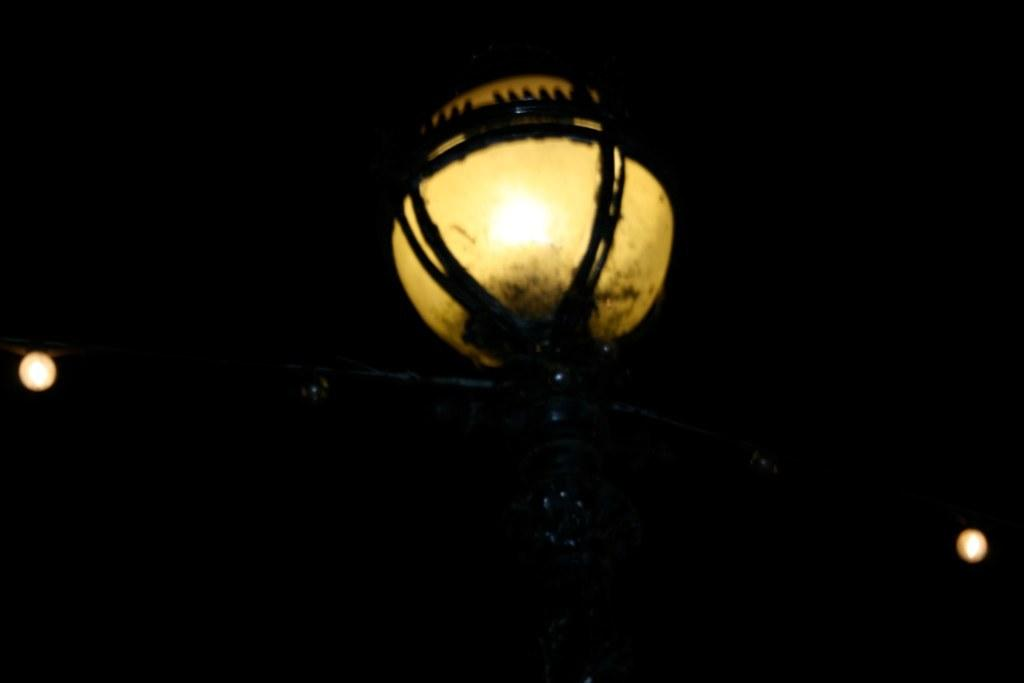What is the main object in the image? There is a light on a pole in the image. Are there any other lights visible in the image? Yes, there are two additional lights, one on the left side and one on the right side. What is the color of the background in the image? The background of the image is black. How many porters are helping the brothers carry the mass in the image? There are no porters, brothers, or masses present in the image. 